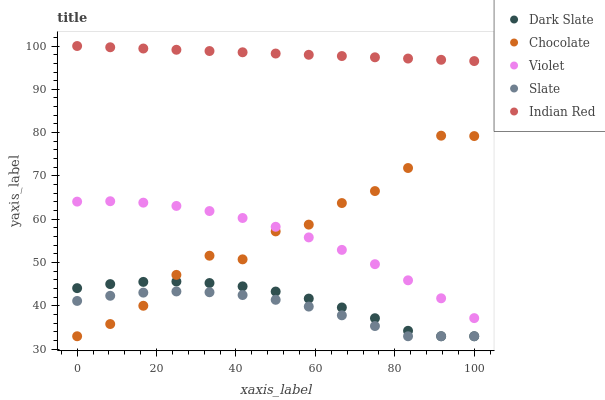Does Slate have the minimum area under the curve?
Answer yes or no. Yes. Does Indian Red have the maximum area under the curve?
Answer yes or no. Yes. Does Violet have the minimum area under the curve?
Answer yes or no. No. Does Violet have the maximum area under the curve?
Answer yes or no. No. Is Indian Red the smoothest?
Answer yes or no. Yes. Is Chocolate the roughest?
Answer yes or no. Yes. Is Slate the smoothest?
Answer yes or no. No. Is Slate the roughest?
Answer yes or no. No. Does Dark Slate have the lowest value?
Answer yes or no. Yes. Does Violet have the lowest value?
Answer yes or no. No. Does Indian Red have the highest value?
Answer yes or no. Yes. Does Violet have the highest value?
Answer yes or no. No. Is Dark Slate less than Violet?
Answer yes or no. Yes. Is Indian Red greater than Violet?
Answer yes or no. Yes. Does Slate intersect Chocolate?
Answer yes or no. Yes. Is Slate less than Chocolate?
Answer yes or no. No. Is Slate greater than Chocolate?
Answer yes or no. No. Does Dark Slate intersect Violet?
Answer yes or no. No. 